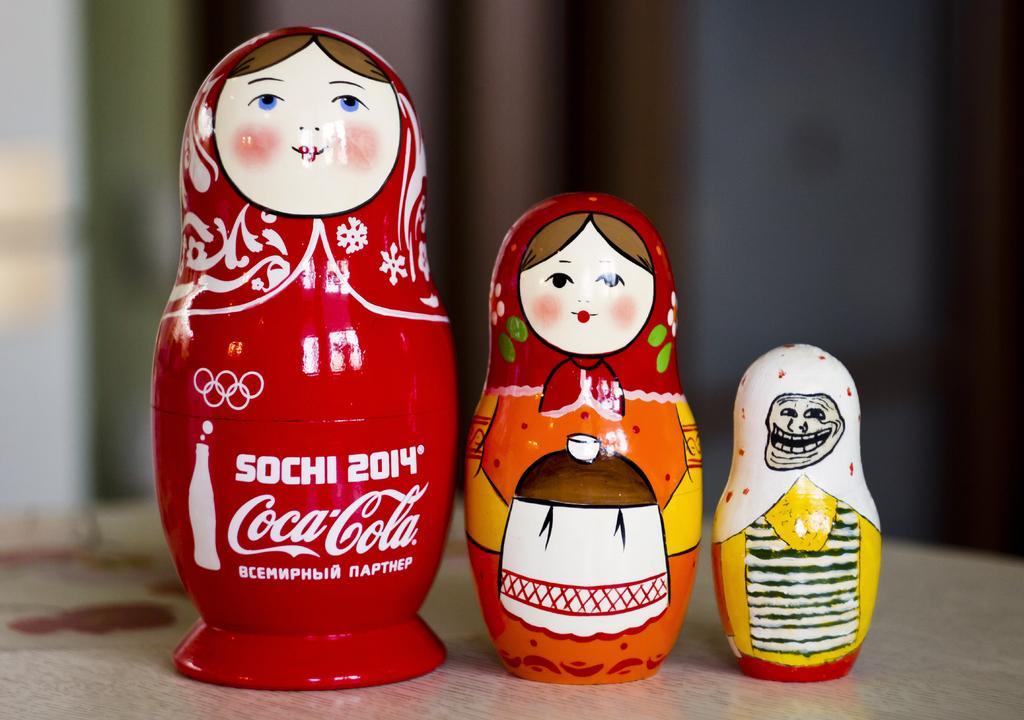Describe this image in one or two sentences. In this image I see 3 dolls and I see something is written over here and I see that it is blurred in the background. 